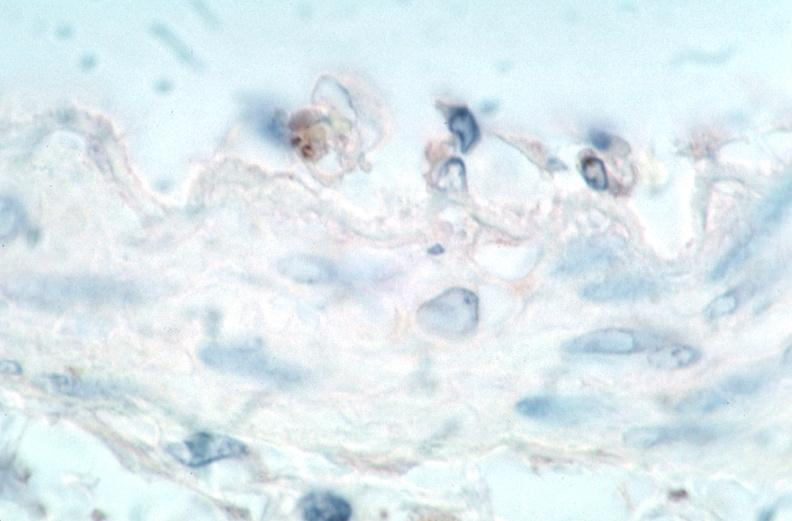does this image show vasculitis?
Answer the question using a single word or phrase. Yes 